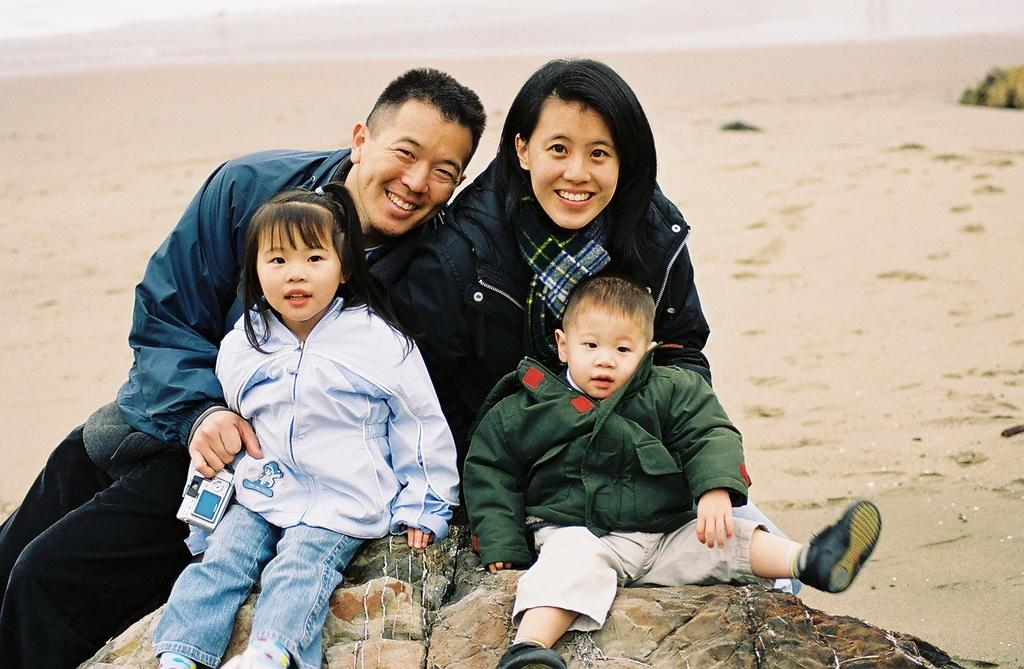Who or what is present in the image? There are people in the image. Where are the people located? The people are on the beach. What can be seen at the bottom of the image? There is a rock at the bottom of the image. What type of roof can be seen on the beach in the image? There is no roof present in the image, as it is set on a beach. 